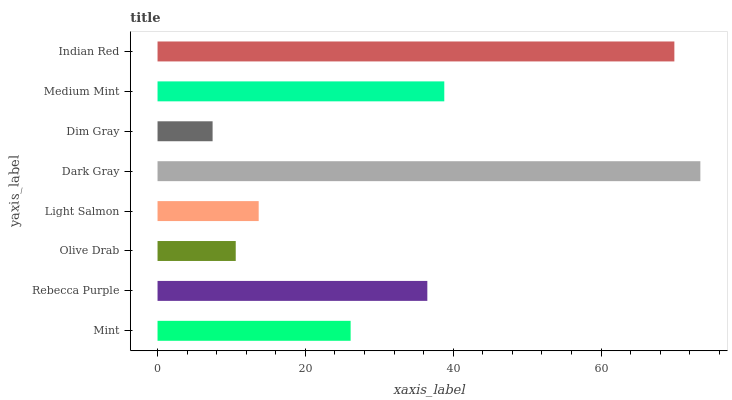Is Dim Gray the minimum?
Answer yes or no. Yes. Is Dark Gray the maximum?
Answer yes or no. Yes. Is Rebecca Purple the minimum?
Answer yes or no. No. Is Rebecca Purple the maximum?
Answer yes or no. No. Is Rebecca Purple greater than Mint?
Answer yes or no. Yes. Is Mint less than Rebecca Purple?
Answer yes or no. Yes. Is Mint greater than Rebecca Purple?
Answer yes or no. No. Is Rebecca Purple less than Mint?
Answer yes or no. No. Is Rebecca Purple the high median?
Answer yes or no. Yes. Is Mint the low median?
Answer yes or no. Yes. Is Dark Gray the high median?
Answer yes or no. No. Is Olive Drab the low median?
Answer yes or no. No. 